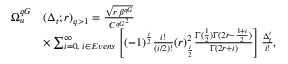<formula> <loc_0><loc_0><loc_500><loc_500>\begin{array} { r l } { \Omega _ { u } ^ { q G } } & { ( \Delta _ { t } ; r ) _ { q > 1 } = \frac { \sqrt { r \, \beta ^ { q G } } } { { C ^ { q G } } ^ { 2 } } } \\ & { \times \sum _ { i = 0 , \, i \in E v e n s } ^ { \infty } \left [ ( - 1 ) ^ { \frac { i } { 2 } } \frac { i ! } { ( i / 2 ) ! } ( r ) _ { \frac { i } { 2 } } ^ { 2 } \frac { \Gamma ( { \frac { 1 } { 2 } ) \Gamma ( { 2 r - \frac { 1 + i } { 2 } } ) } } { \Gamma ( { 2 r + i } ) } \right ] \frac { \Delta _ { t } ^ { i } } { i ! } , } \end{array}</formula> 